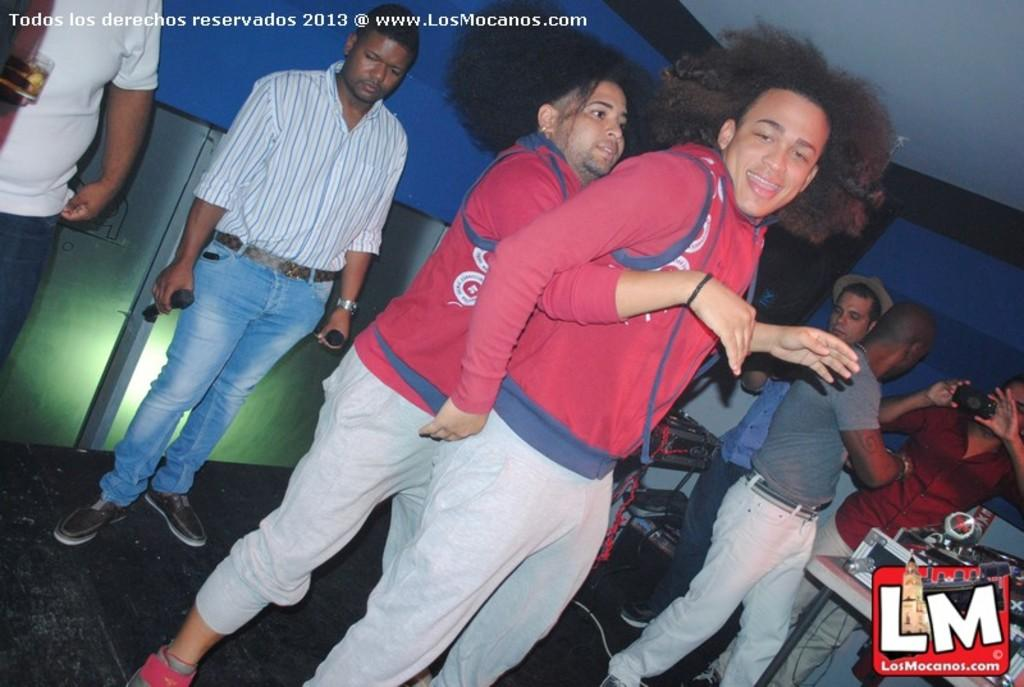What is the main action being performed by the person in the image? There is a person dancing on the floor. What can be seen in the background related to music or entertainment? There are musical instruments in the background. How many people are visible in the background? There is a group of persons in the background. What are the boundaries of the room or space in the image? There is a wall and a ceiling in the background. What type of crate is being used to transport the road in the image? There is no crate or road present in the image; it features a person dancing with musical instruments and a group of persons in the background. 